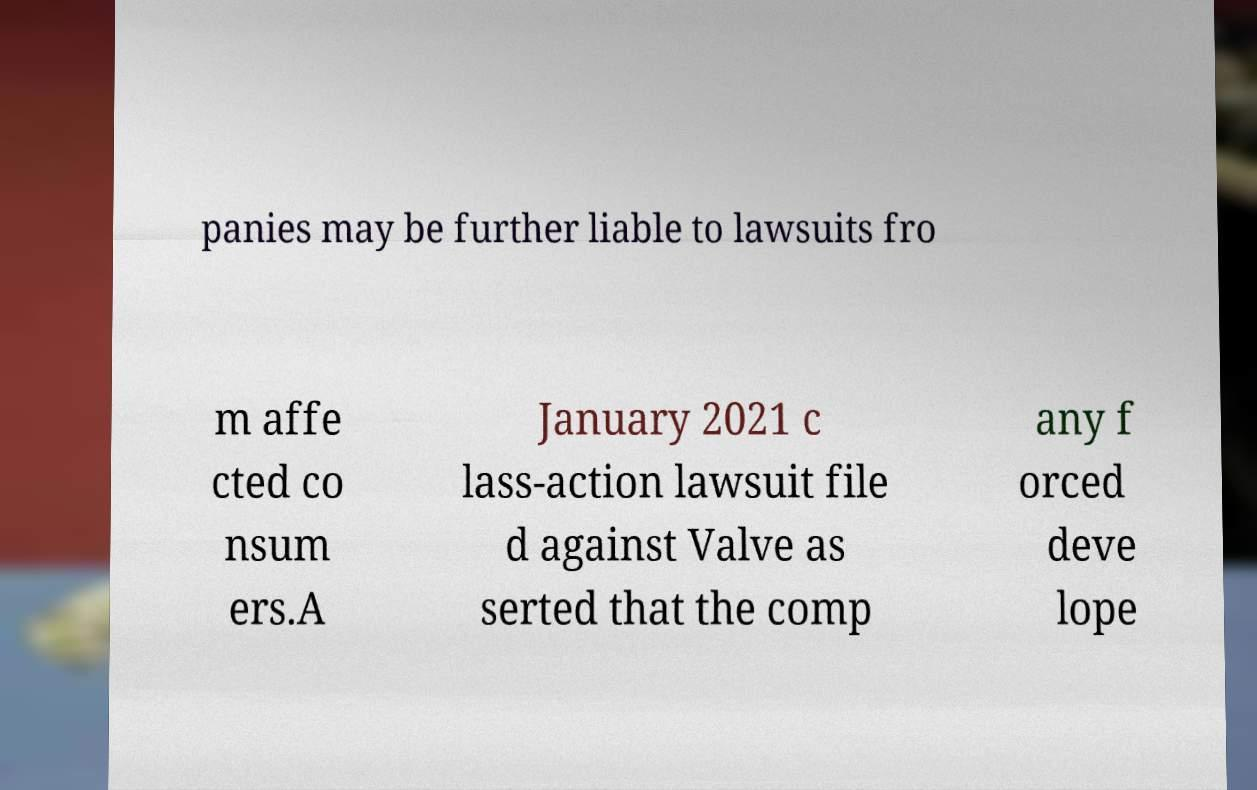Please read and relay the text visible in this image. What does it say? panies may be further liable to lawsuits fro m affe cted co nsum ers.A January 2021 c lass-action lawsuit file d against Valve as serted that the comp any f orced deve lope 